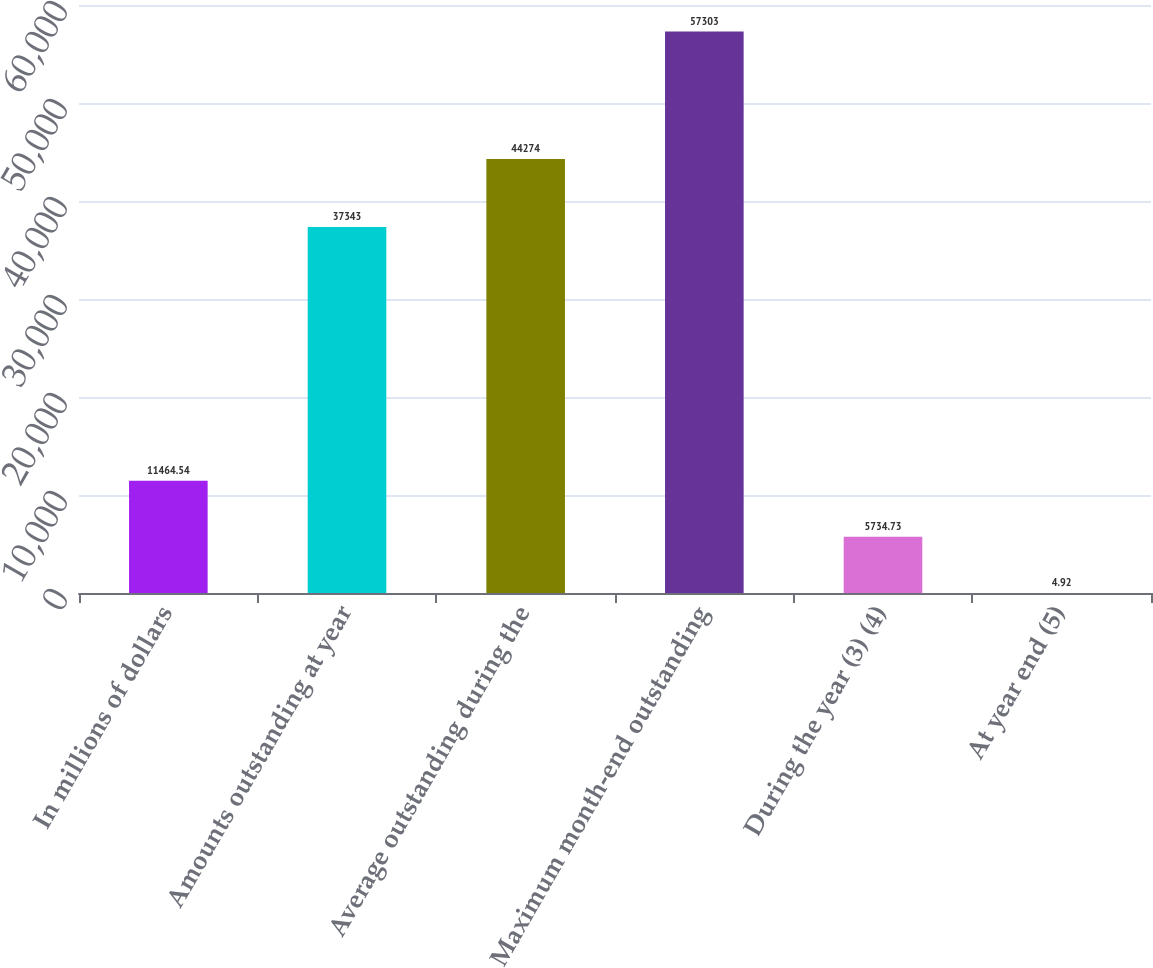Convert chart to OTSL. <chart><loc_0><loc_0><loc_500><loc_500><bar_chart><fcel>In millions of dollars<fcel>Amounts outstanding at year<fcel>Average outstanding during the<fcel>Maximum month-end outstanding<fcel>During the year (3) (4)<fcel>At year end (5)<nl><fcel>11464.5<fcel>37343<fcel>44274<fcel>57303<fcel>5734.73<fcel>4.92<nl></chart> 